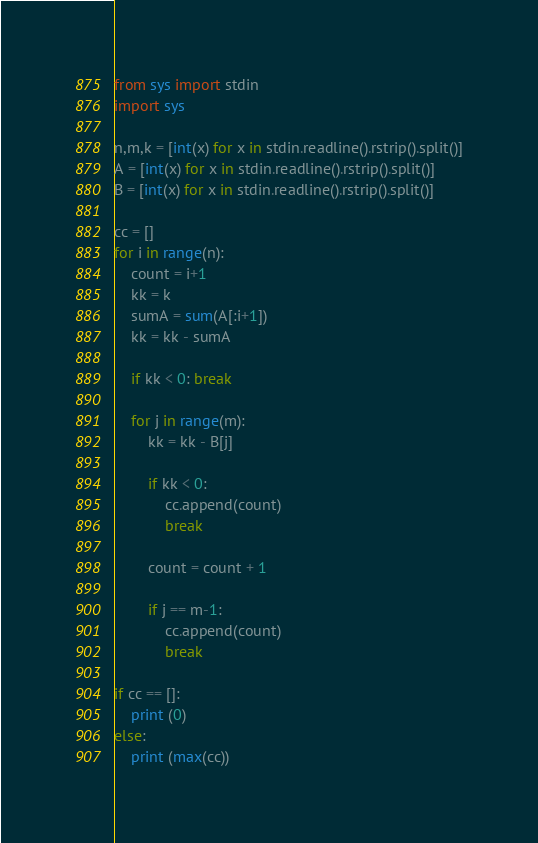Convert code to text. <code><loc_0><loc_0><loc_500><loc_500><_Python_>from sys import stdin
import sys

n,m,k = [int(x) for x in stdin.readline().rstrip().split()]
A = [int(x) for x in stdin.readline().rstrip().split()]
B = [int(x) for x in stdin.readline().rstrip().split()]

cc = []
for i in range(n):
    count = i+1
    kk = k
    sumA = sum(A[:i+1])
    kk = kk - sumA

    if kk < 0: break

    for j in range(m):
        kk = kk - B[j]

        if kk < 0:
            cc.append(count)
            break

        count = count + 1

        if j == m-1:
            cc.append(count)
            break

if cc == []:
    print (0)
else:
    print (max(cc))




</code> 